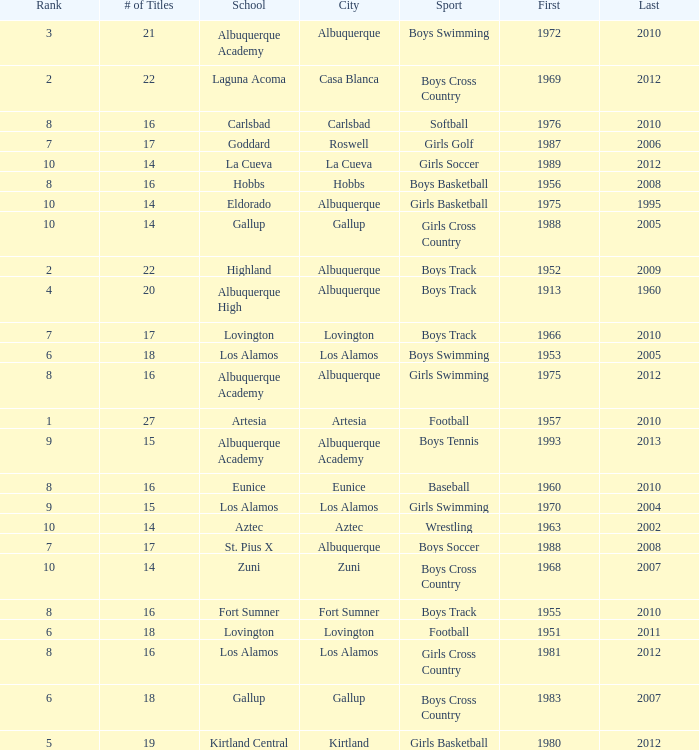What is the total rank number for Los Alamos' girls cross country? 1.0. 